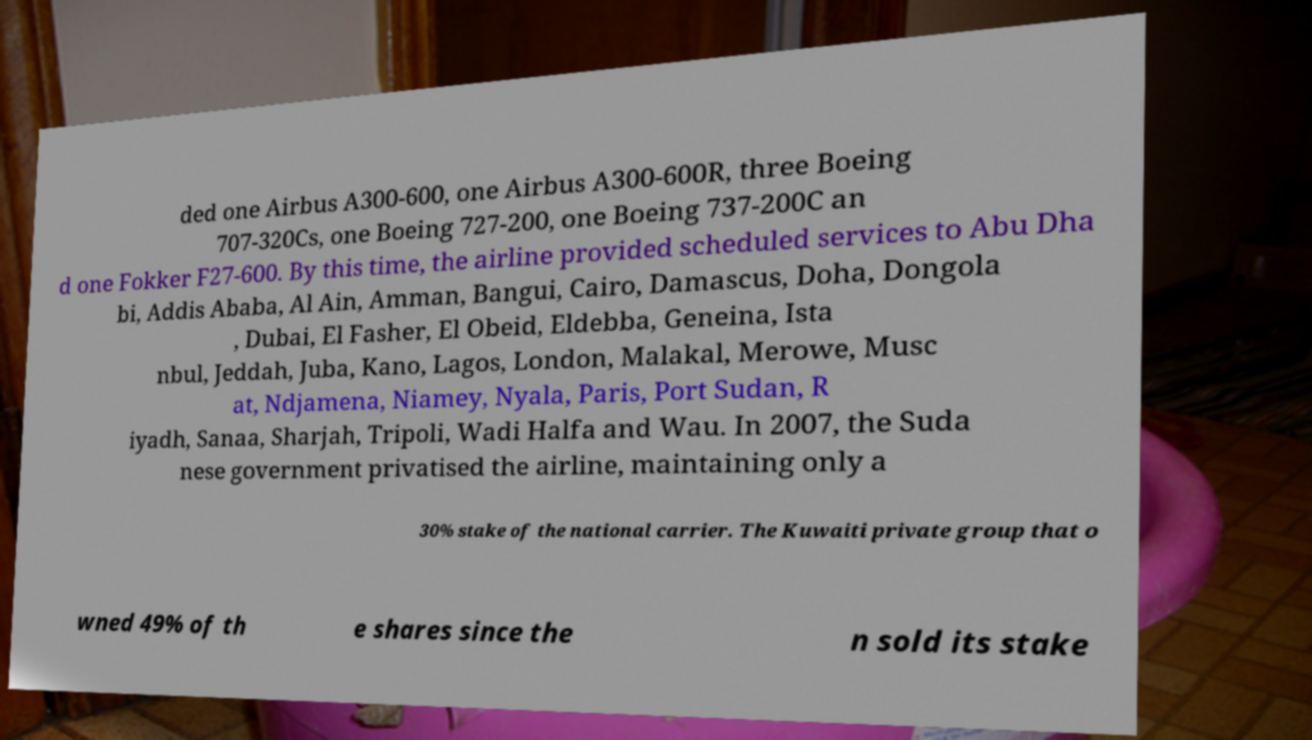Can you accurately transcribe the text from the provided image for me? ded one Airbus A300-600, one Airbus A300-600R, three Boeing 707-320Cs, one Boeing 727-200, one Boeing 737-200C an d one Fokker F27-600. By this time, the airline provided scheduled services to Abu Dha bi, Addis Ababa, Al Ain, Amman, Bangui, Cairo, Damascus, Doha, Dongola , Dubai, El Fasher, El Obeid, Eldebba, Geneina, Ista nbul, Jeddah, Juba, Kano, Lagos, London, Malakal, Merowe, Musc at, Ndjamena, Niamey, Nyala, Paris, Port Sudan, R iyadh, Sanaa, Sharjah, Tripoli, Wadi Halfa and Wau. In 2007, the Suda nese government privatised the airline, maintaining only a 30% stake of the national carrier. The Kuwaiti private group that o wned 49% of th e shares since the n sold its stake 